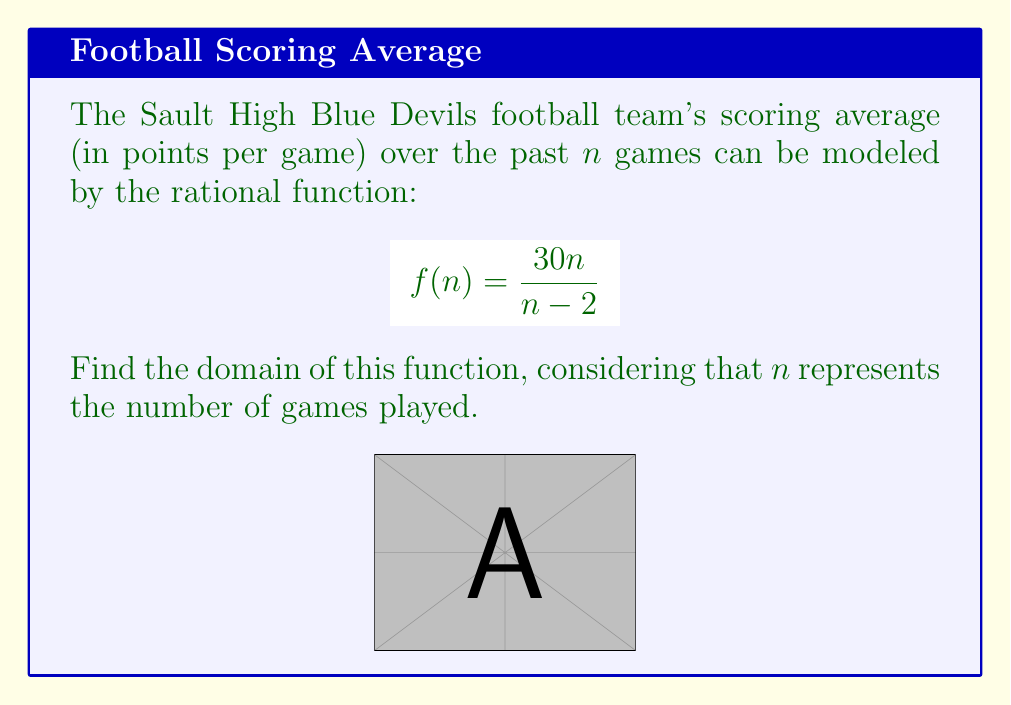What is the answer to this math problem? To find the domain of this rational function, we need to consider two factors:

1. The denominator cannot be zero.
2. The number of games ($n$) must be a positive integer.

Step 1: Set the denominator equal to zero and solve for $n$.
$$n - 2 = 0$$
$$n = 2$$

This means that $n$ cannot equal 2, as it would make the denominator zero and the function undefined.

Step 2: Consider the restrictions on $n$ based on its real-world meaning.
Since $n$ represents the number of games played, it must be a positive integer.

Step 3: Combine these conditions to determine the domain.
The domain includes all positive integers except 2.

We can express this mathematically as:
$$\{n \in \mathbb{Z}^+ : n \neq 2\}$$

Or in interval notation:
$$\{1\} \cup \{3, 4, 5, ...\}$$
Answer: $\{n \in \mathbb{Z}^+ : n \neq 2\}$ 